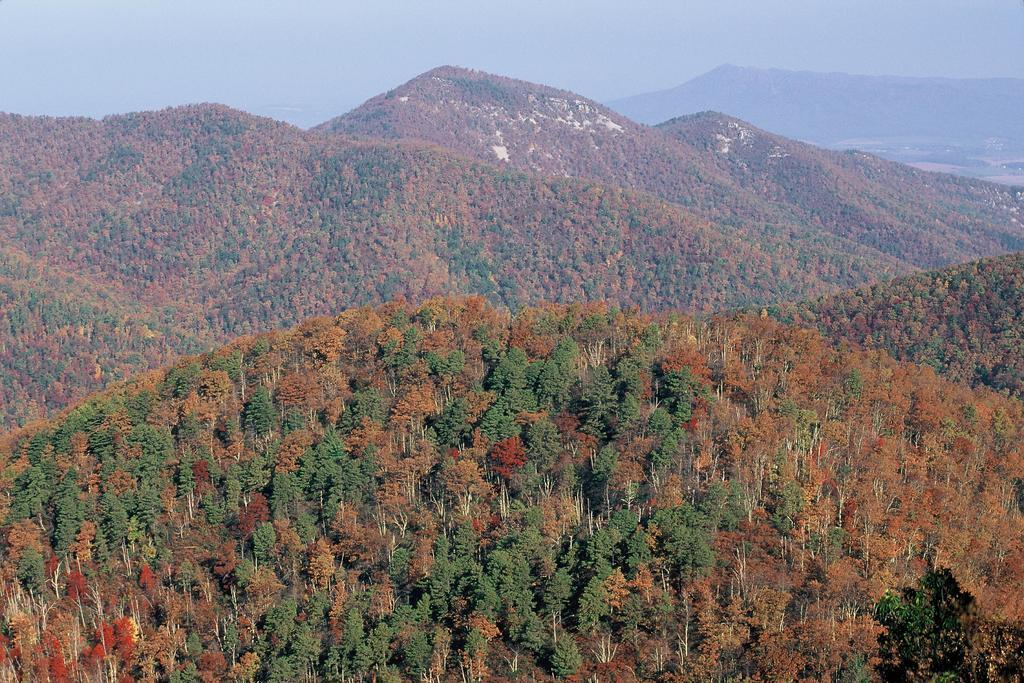What type of vegetation is present in the image? There are trees in the image. What colors can be seen on the trees? The trees have brown and green colors. What can be seen in the distance behind the trees? There are hills in the background of the image. What is visible above the trees and hills? The sky is visible in the background of the image. What type of insect can be seen crawling on the brick building in the image? There is no insect or brick building present in the image; it features trees, hills, and the sky. 